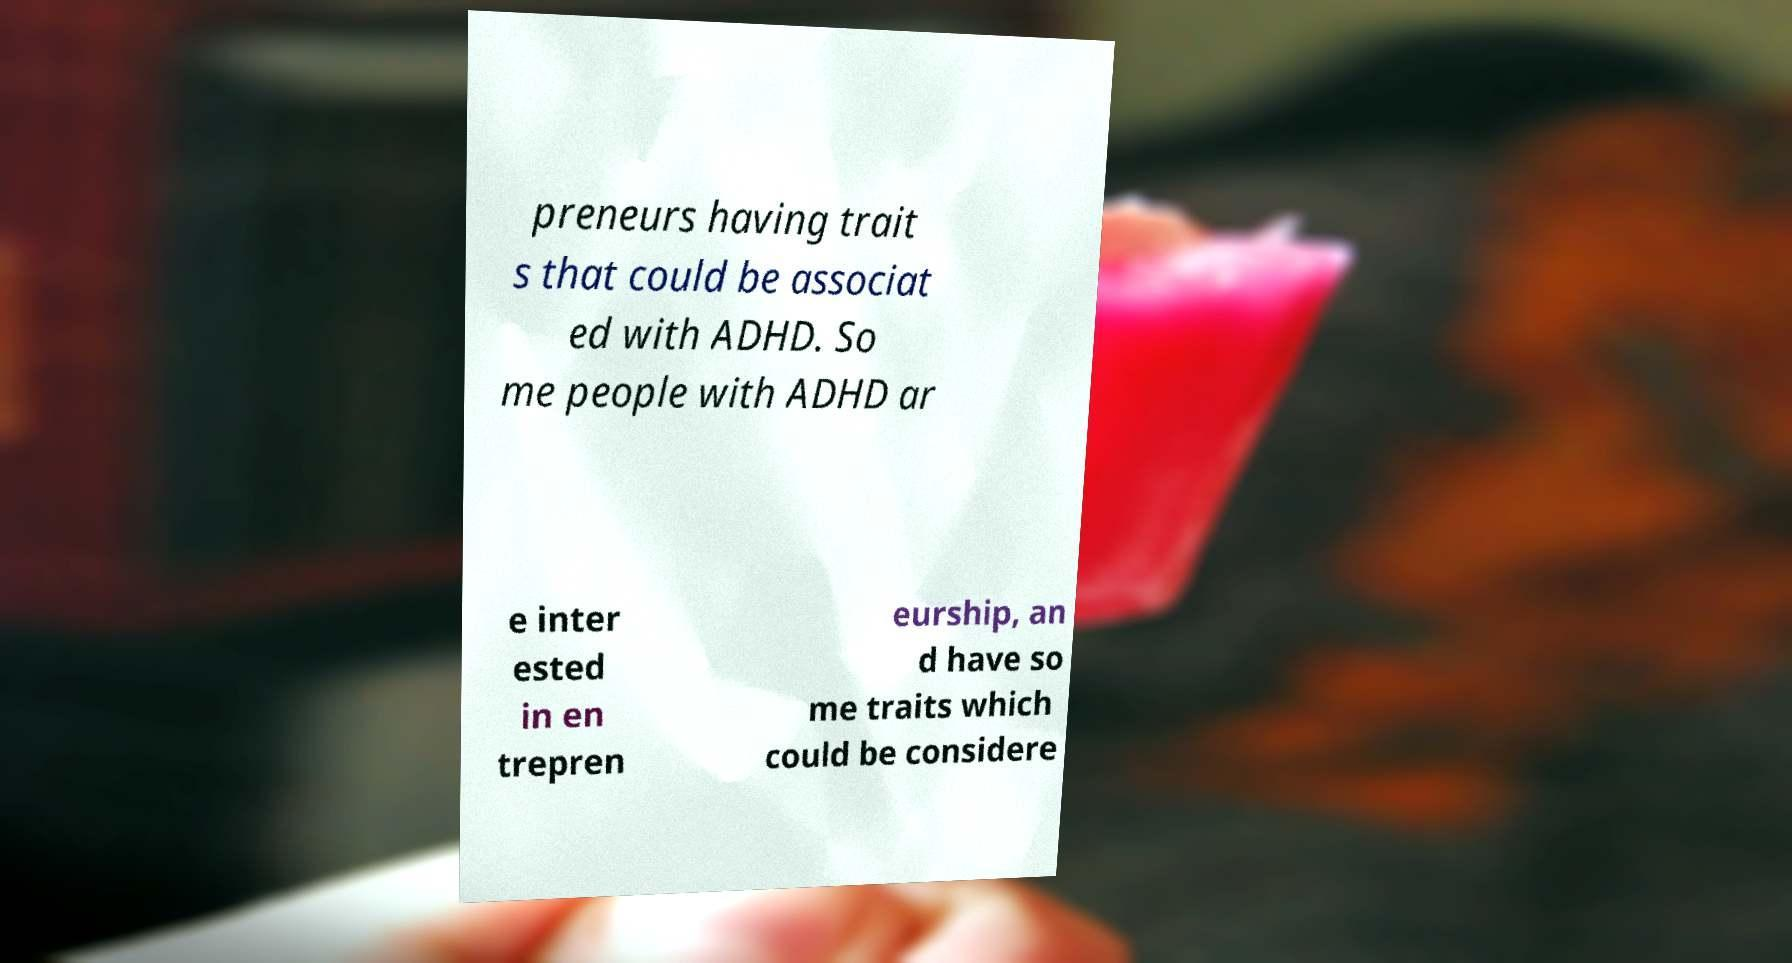Please identify and transcribe the text found in this image. preneurs having trait s that could be associat ed with ADHD. So me people with ADHD ar e inter ested in en trepren eurship, an d have so me traits which could be considere 